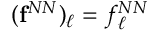Convert formula to latex. <formula><loc_0><loc_0><loc_500><loc_500>( { f } ^ { N N } ) _ { \ell } = f _ { \ell } ^ { N N }</formula> 